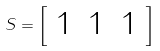Convert formula to latex. <formula><loc_0><loc_0><loc_500><loc_500>S = { \left [ \begin{array} { l l l } { 1 } & { 1 } & { 1 } \end{array} \right ] }</formula> 